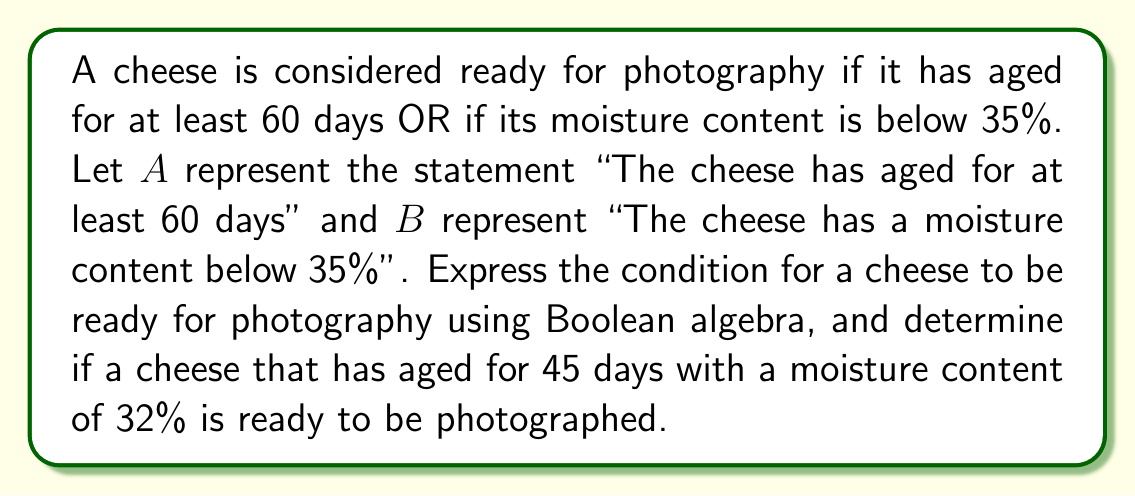Could you help me with this problem? 1. Let's express the condition for a cheese to be ready for photography using Boolean algebra:

   Ready for photography = $A + B$

   Where $+$ represents the Boolean OR operation.

2. Now, let's evaluate the given scenario:
   - The cheese has aged for 45 days, which is less than 60 days. So, $A = 0$ (false)
   - The cheese has a moisture content of 32%, which is below 35%. So, $B = 1$ (true)

3. Let's apply these values to our Boolean expression:

   Ready for photography = $A + B = 0 + 1$

4. In Boolean algebra, $0 + 1 = 1$

Therefore, the result is 1 (true), meaning the cheese is ready for photography.
Answer: Yes, ready for photography 